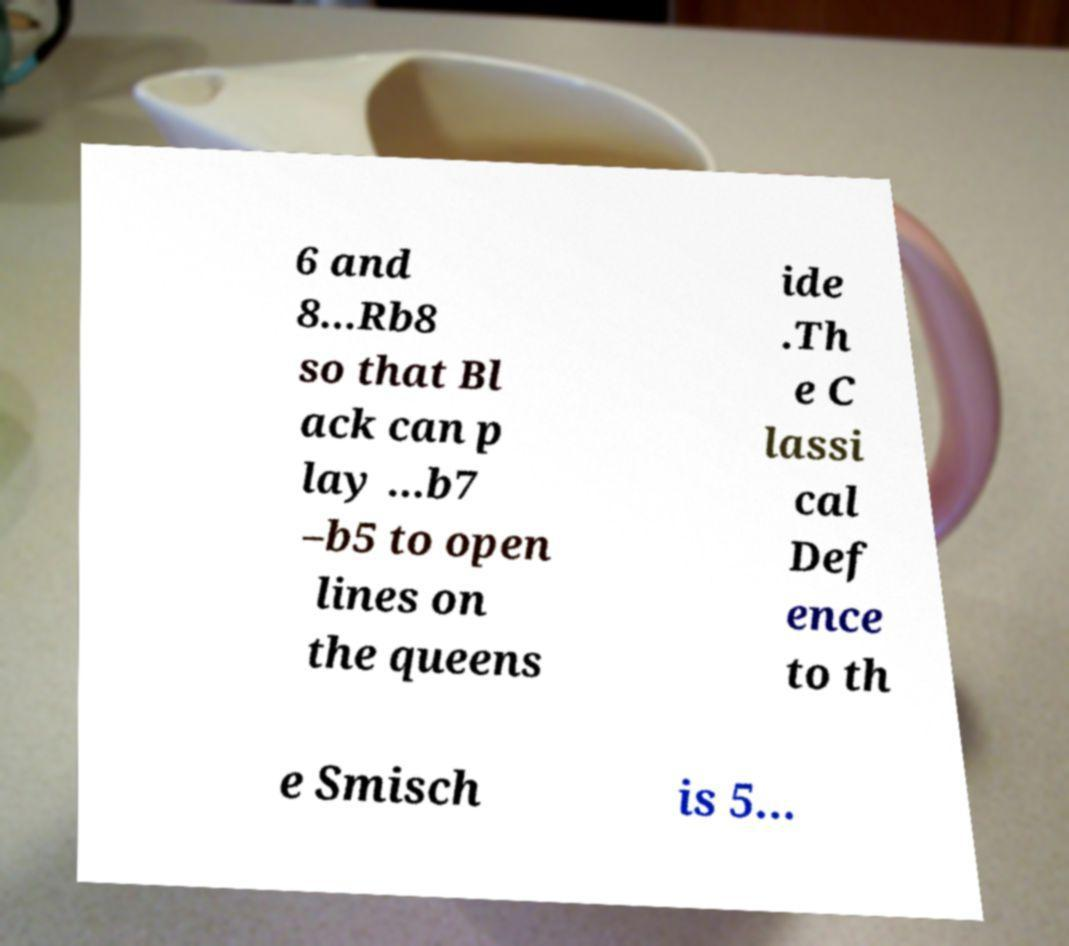Can you read and provide the text displayed in the image?This photo seems to have some interesting text. Can you extract and type it out for me? 6 and 8...Rb8 so that Bl ack can p lay ...b7 –b5 to open lines on the queens ide .Th e C lassi cal Def ence to th e Smisch is 5... 